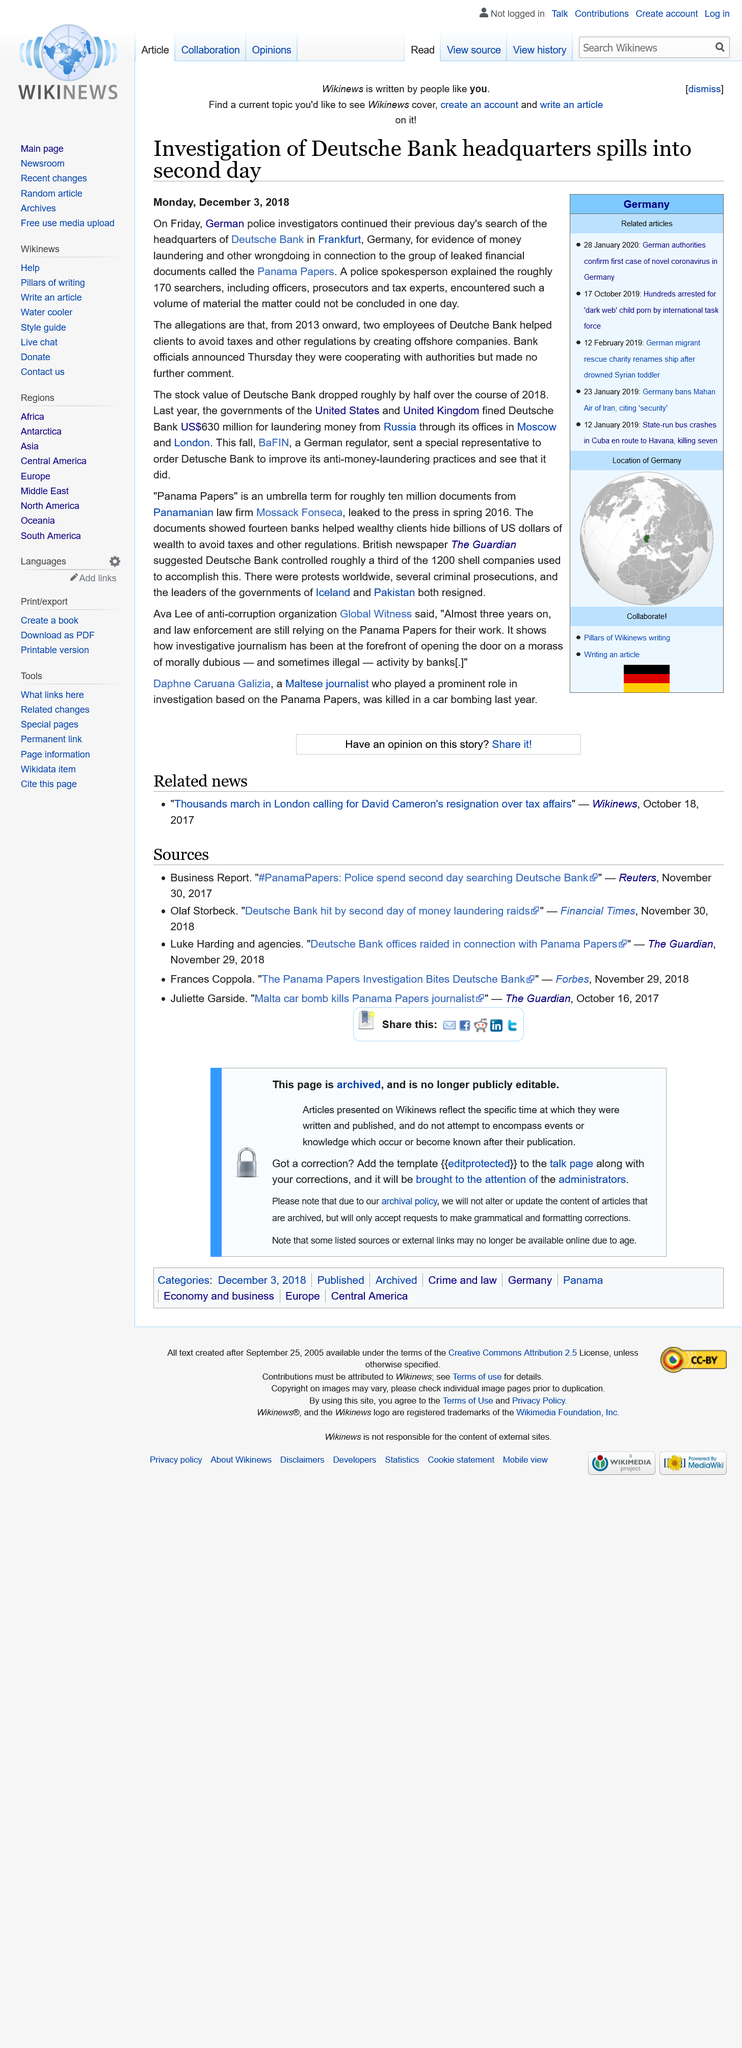Draw attention to some important aspects in this diagram. Deutsche Bank was fined US$630 million. The headquarters of Deutsche Bank are located in Frankfurt, according to an article published on Monday, December 3rd, 2018, as stated in the article. The leaked financial documents are known as the Panama Papers. 